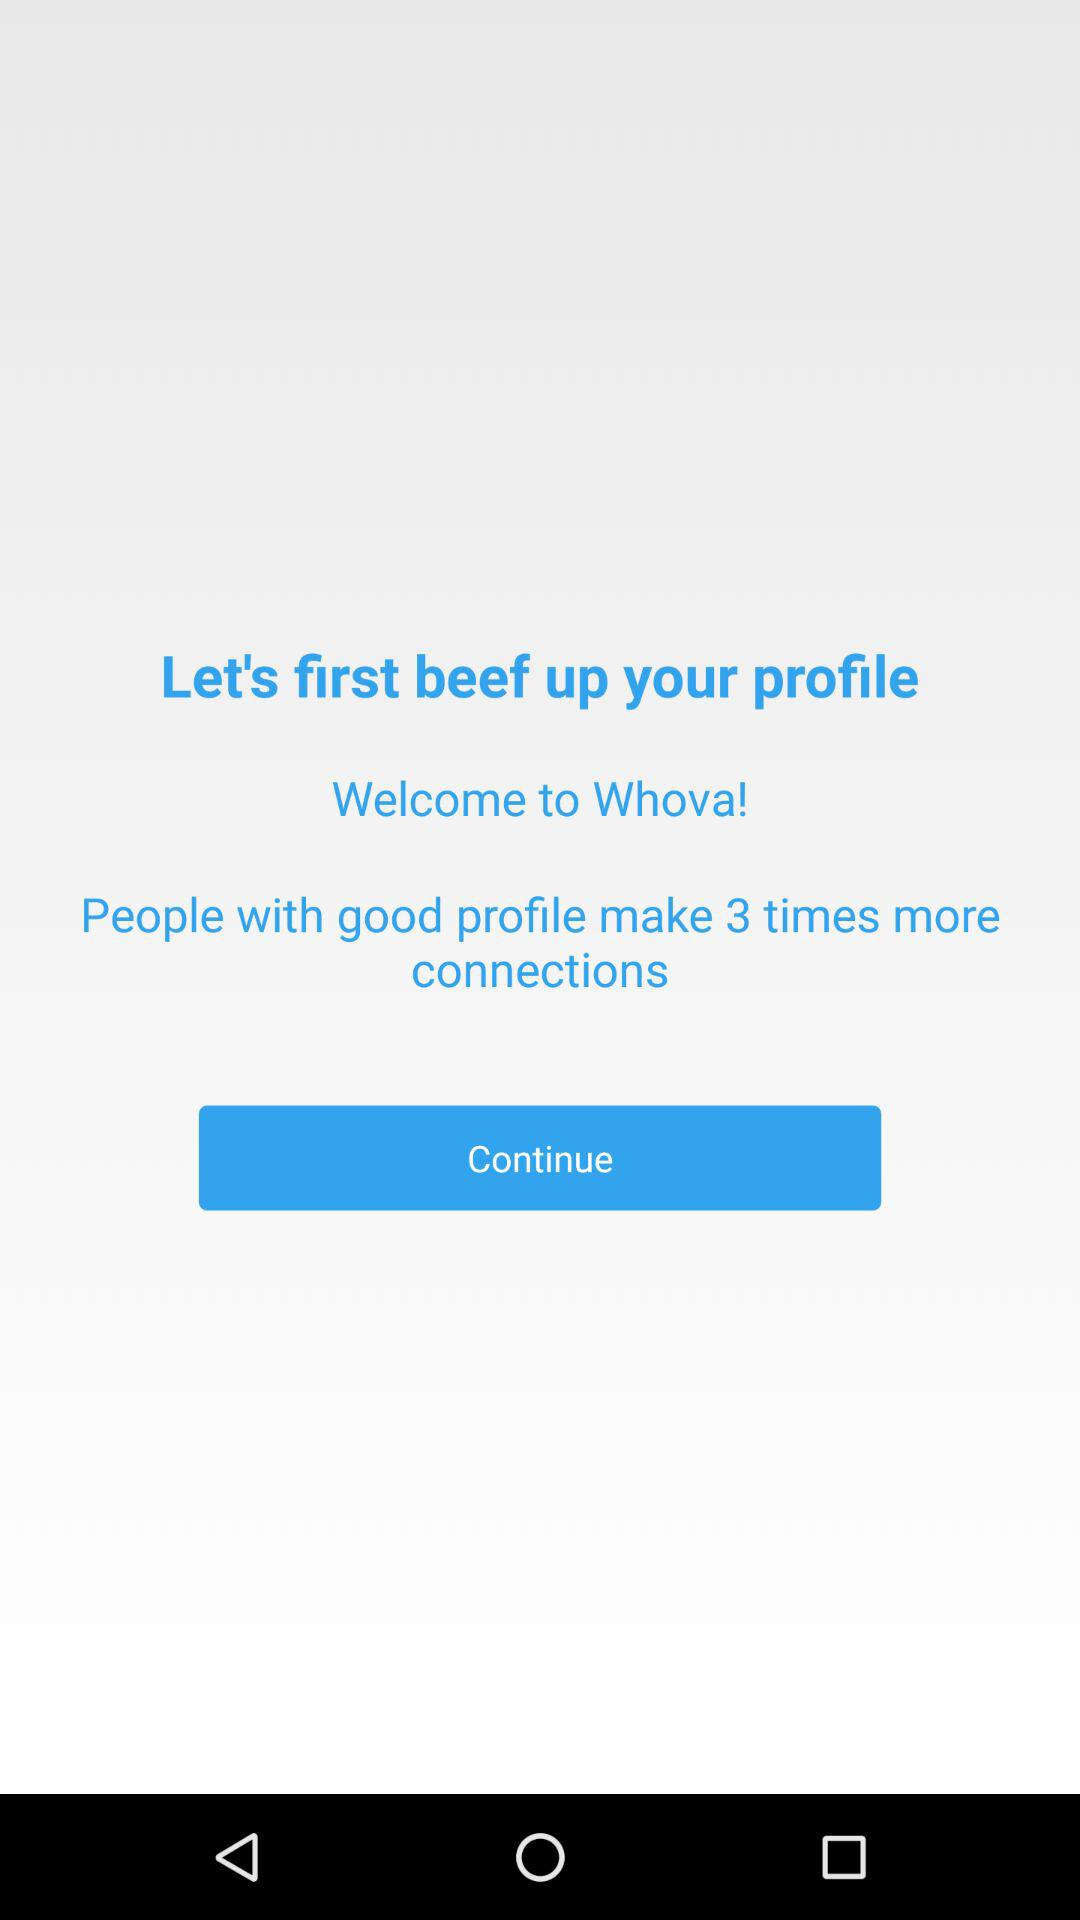What is the application name? The application name is "Whova". 